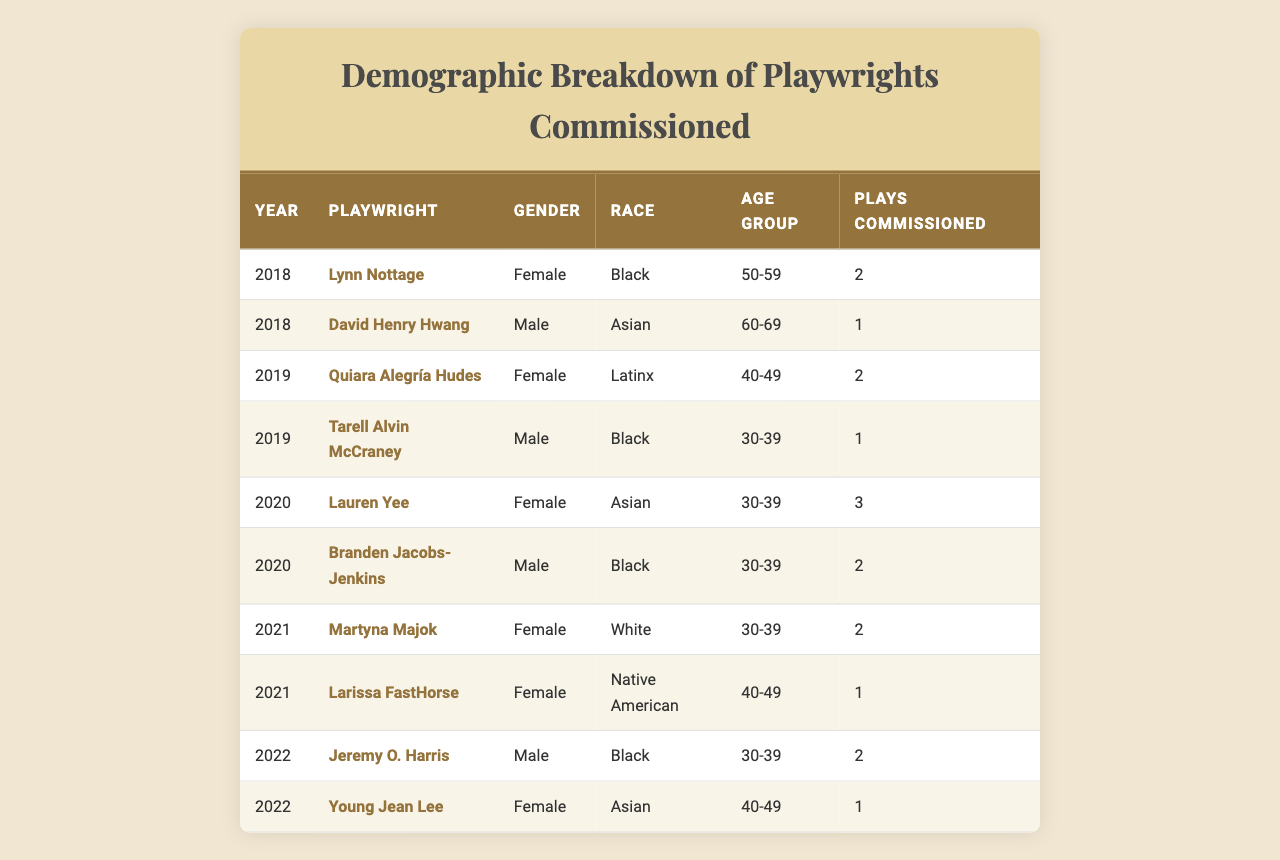What is the total number of plays commissioned in 2019? In 2019, there are two playwrights listed: Quiara Alegría Hudes with 2 plays and Tarell Alvin McCraney with 1 play. Summing these gives 2 + 1 = 3.
Answer: 3 Which gender was commissioned more in 2020? In 2020, there are two female playwrights (Lauren Yee with 3 plays) and one male playwright (Branden Jacobs-Jenkins with 2 plays). Comparing the numbers, females had 3 commissioned while males had 2. Therefore, females were commissioned more.
Answer: Female How many Black playwrights were commissioned across all years? From the table, the Black playwrights are Lynn Nottage (2), Tarell Alvin McCraney (1), Branden Jacobs-Jenkins (2), and Jeremy O. Harris (2). Summing these gives 2 + 1 + 2 + 2 = 7.
Answer: 7 What is the average number of plays commissioned per year? The total number of plays is 2 + 1 + 2 + 1 + 3 + 2 + 2 + 1 = 14. The number of years is 5 (2018, 2019, 2020, 2021, 2022). Therefore, the average is 14 / 5 = 2.8.
Answer: 2.8 Did any Native American playwrights have plays commissioned in 2019? Looking through the table, there are no entries for Native American playwrights in 2019. The only one listed is Larissa FastHorse in 2021. Thus, the answer is no.
Answer: No Who is the youngest playwright among those commissioned in 2021? In 2021, Martyna Majok and Larissa FastHorse were both commissioned. Their age groups are 30-39 (Martyna) and 40-49 (Larissa), indicating Martyna is younger since 30-39 is the lower age range.
Answer: Martyna Majok What is the ratio of male to female playwrights commissioned in 2022? In 2022, there are one male (Jeremy O. Harris with 2 plays) and one female (Young Jean Lee with 1 play) playwright. This results in a 1:1 ratio of male to female commissioned playwrights.
Answer: 1:1 Which age group had the most plays commissioned? The age groups are 30-39 (Branden Jacobs-Jenkins, Lauren Yee, Jeremy O. Harris with 2 + 3 + 2 = 7), 40-49 (Quiara Alegría Hudes, Young Jean Lee, Larissa FastHorse with 2 + 1 + 1 = 4), 50-59 (Lynn Nottage with 2), and 60-69 (David Henry Hwang with 1). The age group 30-39 had the most with 7 plays commissioned.
Answer: 30-39 How many more plays were commissioned by females compared to males in 2020? In 2020, Lauren Yee (3) and  Branden Jacobs-Jenkins (2) were commissioned. Thus, females had 3 plays while males had 2. Therefore, females were commissioned 1 more play than males (3 - 2 = 1).
Answer: 1 Is there at least one playwright from each race represented in the data? Reviewing the table, we see Black (Lynn Nottage, Tarell Alvin McCraney, Branden Jacobs-Jenkins, Jeremy O. Harris), Asian (David Henry Hwang, Lauren Yee, Young Jean Lee), Latinx (Quiara Alegría Hudes), White (Martyna Majok), and Native American (Larissa FastHorse) are all represented. Therefore, the statement is true.
Answer: Yes 